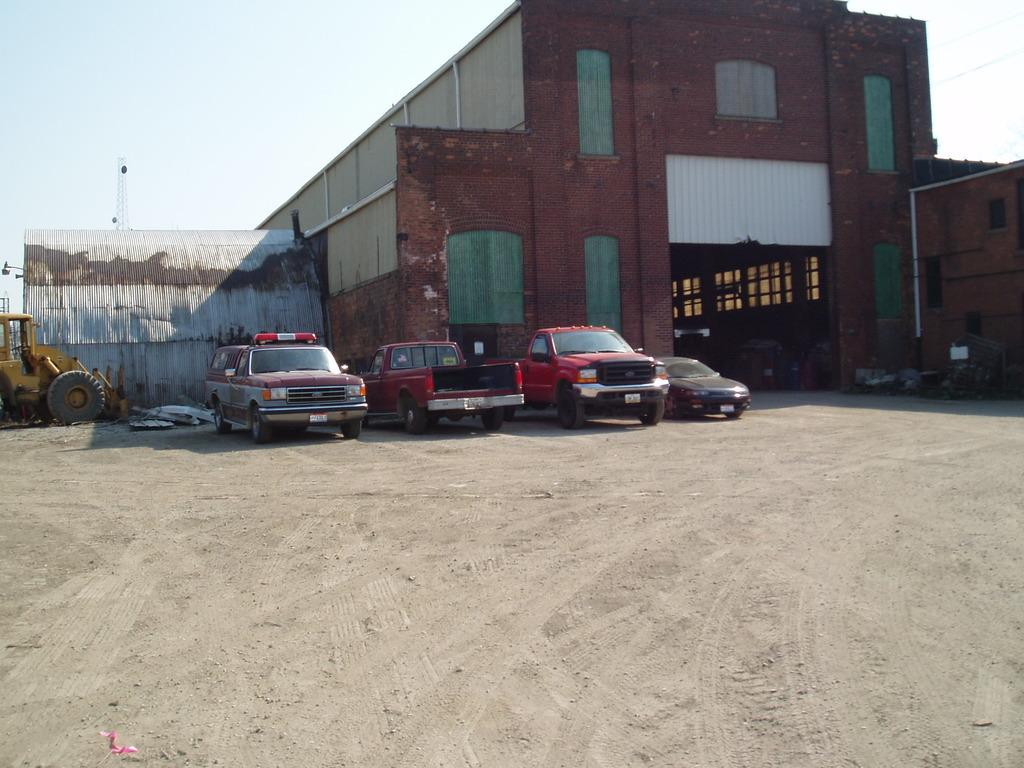What types of vehicles are in the image? The image contains vehicles, but the specific types are not mentioned. What can be seen in the background of the image? There is a building and the sky visible in the background of the image. Where is the tower located in the image? The tower is on the left side of the image. What year is depicted in the image? The year is not depicted in the image, as it does not contain any elements that would indicate a specific time period. 